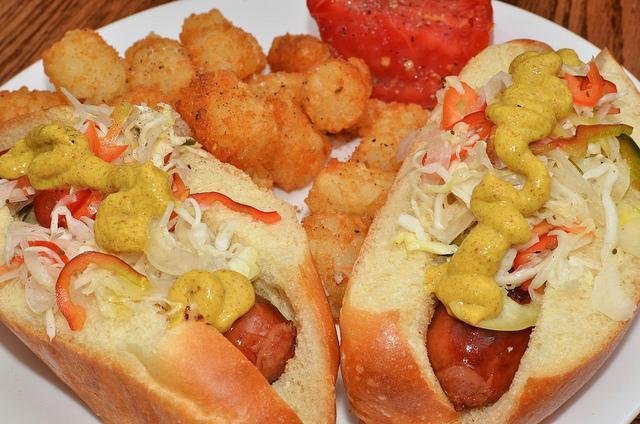How many hot dogs are there?
Give a very brief answer. 2. How many levels does the bus have?
Give a very brief answer. 0. 